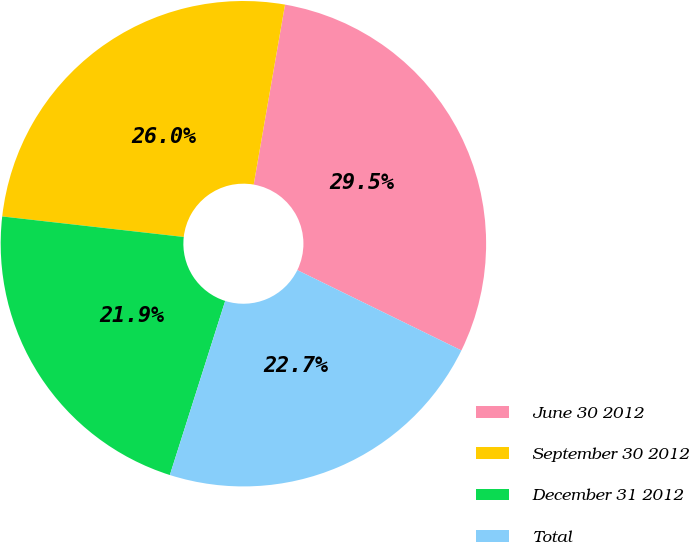Convert chart. <chart><loc_0><loc_0><loc_500><loc_500><pie_chart><fcel>June 30 2012<fcel>September 30 2012<fcel>December 31 2012<fcel>Total<nl><fcel>29.5%<fcel>25.95%<fcel>21.89%<fcel>22.65%<nl></chart> 